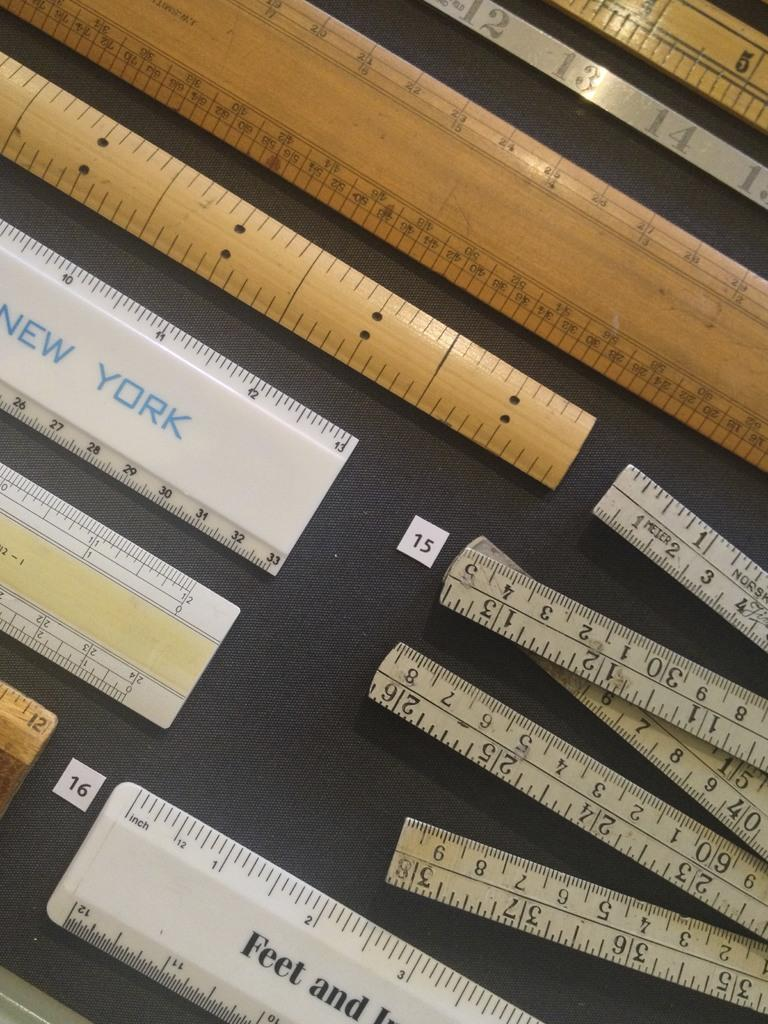<image>
Offer a succinct explanation of the picture presented. Several rulers on display one is plastic and says NEW YORK on the side. 